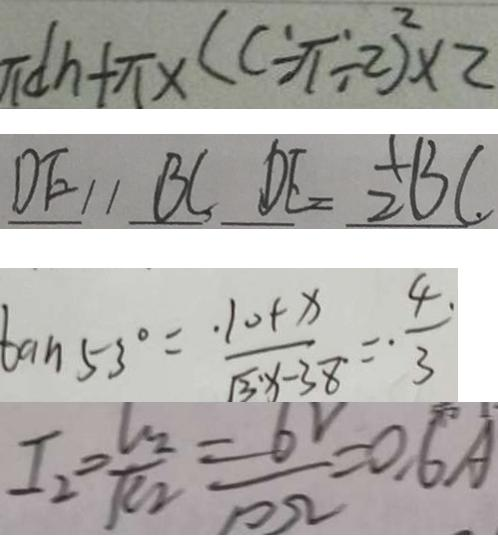<formula> <loc_0><loc_0><loc_500><loc_500>\pi d h + \pi \times ( c \div \pi \div 2 ) ^ { 2 } \times 2 
 D E / / B C D E = 2 B C 
 \tan 5 3 ^ { \circ } = \frac { 1 0 + x } { \sqrt { 3 } x - 3 8 } = \frac { 4 } { 3 } 
 I _ { 2 } = \frac { V _ { 2 } } { R _ { 2 } } = \frac { 6 } { 1 0 \Omega } = 0 . 6 A</formula> 